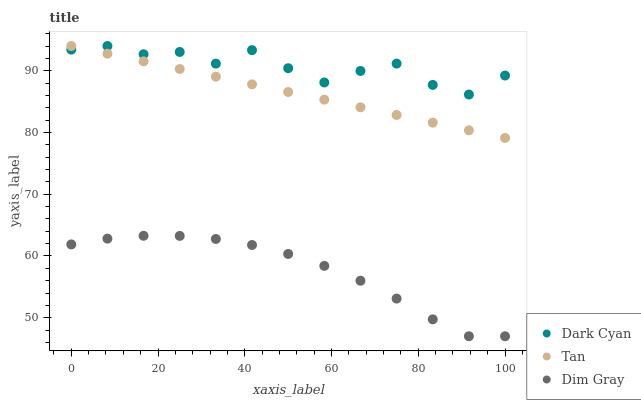Does Dim Gray have the minimum area under the curve?
Answer yes or no. Yes. Does Dark Cyan have the maximum area under the curve?
Answer yes or no. Yes. Does Tan have the minimum area under the curve?
Answer yes or no. No. Does Tan have the maximum area under the curve?
Answer yes or no. No. Is Tan the smoothest?
Answer yes or no. Yes. Is Dark Cyan the roughest?
Answer yes or no. Yes. Is Dim Gray the smoothest?
Answer yes or no. No. Is Dim Gray the roughest?
Answer yes or no. No. Does Dim Gray have the lowest value?
Answer yes or no. Yes. Does Tan have the lowest value?
Answer yes or no. No. Does Tan have the highest value?
Answer yes or no. Yes. Does Dim Gray have the highest value?
Answer yes or no. No. Is Dim Gray less than Tan?
Answer yes or no. Yes. Is Tan greater than Dim Gray?
Answer yes or no. Yes. Does Dark Cyan intersect Tan?
Answer yes or no. Yes. Is Dark Cyan less than Tan?
Answer yes or no. No. Is Dark Cyan greater than Tan?
Answer yes or no. No. Does Dim Gray intersect Tan?
Answer yes or no. No. 